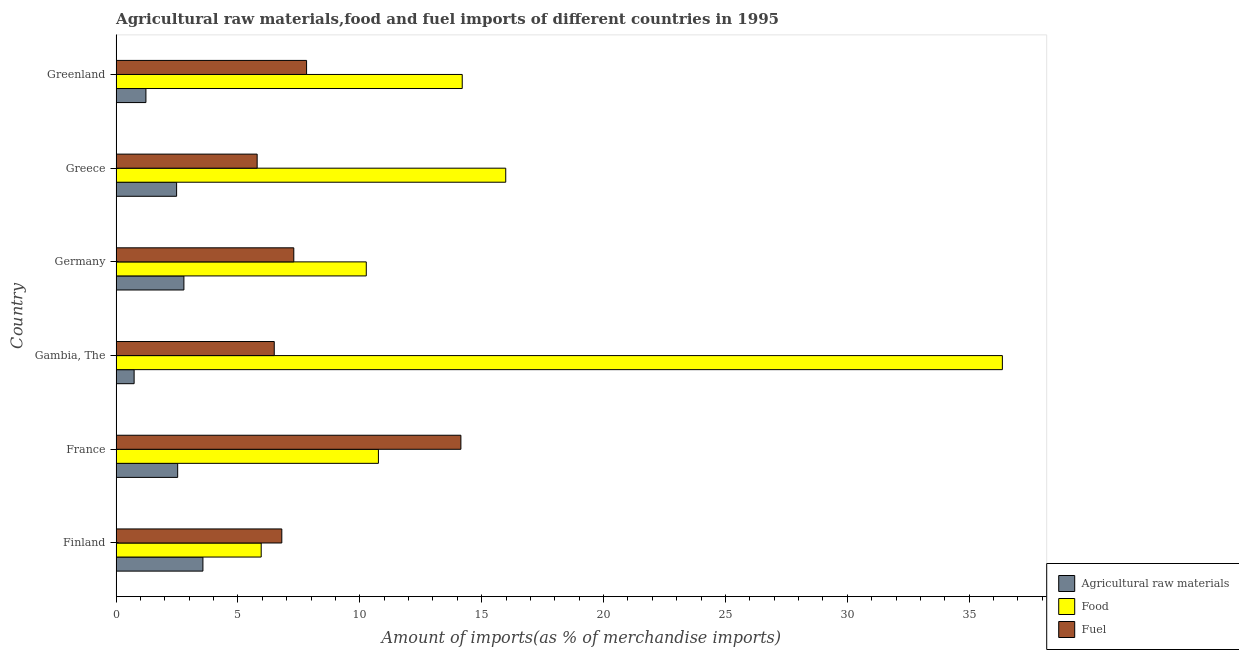How many different coloured bars are there?
Provide a succinct answer. 3. Are the number of bars per tick equal to the number of legend labels?
Ensure brevity in your answer.  Yes. What is the label of the 1st group of bars from the top?
Offer a very short reply. Greenland. In how many cases, is the number of bars for a given country not equal to the number of legend labels?
Keep it short and to the point. 0. What is the percentage of food imports in Germany?
Offer a terse response. 10.26. Across all countries, what is the maximum percentage of food imports?
Provide a succinct answer. 36.36. Across all countries, what is the minimum percentage of food imports?
Keep it short and to the point. 5.95. In which country was the percentage of food imports maximum?
Give a very brief answer. Gambia, The. What is the total percentage of fuel imports in the graph?
Keep it short and to the point. 48.32. What is the difference between the percentage of raw materials imports in France and that in Gambia, The?
Your answer should be compact. 1.79. What is the difference between the percentage of raw materials imports in Greenland and the percentage of fuel imports in France?
Give a very brief answer. -12.92. What is the average percentage of fuel imports per country?
Offer a terse response. 8.05. What is the difference between the percentage of food imports and percentage of fuel imports in Greenland?
Keep it short and to the point. 6.39. In how many countries, is the percentage of raw materials imports greater than 9 %?
Your response must be concise. 0. What is the ratio of the percentage of raw materials imports in France to that in Greenland?
Give a very brief answer. 2.06. Is the percentage of fuel imports in Germany less than that in Greece?
Your answer should be very brief. No. Is the difference between the percentage of raw materials imports in Germany and Greenland greater than the difference between the percentage of food imports in Germany and Greenland?
Give a very brief answer. Yes. What is the difference between the highest and the second highest percentage of fuel imports?
Provide a short and direct response. 6.33. What is the difference between the highest and the lowest percentage of fuel imports?
Offer a very short reply. 8.36. In how many countries, is the percentage of food imports greater than the average percentage of food imports taken over all countries?
Offer a terse response. 2. Is the sum of the percentage of food imports in Finland and Germany greater than the maximum percentage of fuel imports across all countries?
Your answer should be compact. Yes. What does the 3rd bar from the top in Finland represents?
Provide a succinct answer. Agricultural raw materials. What does the 1st bar from the bottom in Greece represents?
Your answer should be compact. Agricultural raw materials. Are all the bars in the graph horizontal?
Ensure brevity in your answer.  Yes. How many countries are there in the graph?
Your answer should be very brief. 6. What is the difference between two consecutive major ticks on the X-axis?
Give a very brief answer. 5. Are the values on the major ticks of X-axis written in scientific E-notation?
Make the answer very short. No. Does the graph contain grids?
Your answer should be compact. No. Where does the legend appear in the graph?
Give a very brief answer. Bottom right. What is the title of the graph?
Ensure brevity in your answer.  Agricultural raw materials,food and fuel imports of different countries in 1995. Does "Social Insurance" appear as one of the legend labels in the graph?
Your response must be concise. No. What is the label or title of the X-axis?
Your response must be concise. Amount of imports(as % of merchandise imports). What is the Amount of imports(as % of merchandise imports) in Agricultural raw materials in Finland?
Your answer should be very brief. 3.56. What is the Amount of imports(as % of merchandise imports) in Food in Finland?
Make the answer very short. 5.95. What is the Amount of imports(as % of merchandise imports) of Fuel in Finland?
Your answer should be very brief. 6.8. What is the Amount of imports(as % of merchandise imports) of Agricultural raw materials in France?
Your response must be concise. 2.53. What is the Amount of imports(as % of merchandise imports) of Food in France?
Provide a succinct answer. 10.76. What is the Amount of imports(as % of merchandise imports) of Fuel in France?
Provide a short and direct response. 14.15. What is the Amount of imports(as % of merchandise imports) of Agricultural raw materials in Gambia, The?
Make the answer very short. 0.74. What is the Amount of imports(as % of merchandise imports) of Food in Gambia, The?
Offer a very short reply. 36.36. What is the Amount of imports(as % of merchandise imports) of Fuel in Gambia, The?
Provide a succinct answer. 6.49. What is the Amount of imports(as % of merchandise imports) in Agricultural raw materials in Germany?
Ensure brevity in your answer.  2.78. What is the Amount of imports(as % of merchandise imports) in Food in Germany?
Provide a short and direct response. 10.26. What is the Amount of imports(as % of merchandise imports) of Fuel in Germany?
Provide a short and direct response. 7.29. What is the Amount of imports(as % of merchandise imports) of Agricultural raw materials in Greece?
Ensure brevity in your answer.  2.48. What is the Amount of imports(as % of merchandise imports) of Food in Greece?
Make the answer very short. 15.99. What is the Amount of imports(as % of merchandise imports) in Fuel in Greece?
Give a very brief answer. 5.79. What is the Amount of imports(as % of merchandise imports) of Agricultural raw materials in Greenland?
Make the answer very short. 1.22. What is the Amount of imports(as % of merchandise imports) of Food in Greenland?
Your answer should be very brief. 14.2. What is the Amount of imports(as % of merchandise imports) of Fuel in Greenland?
Your response must be concise. 7.81. Across all countries, what is the maximum Amount of imports(as % of merchandise imports) of Agricultural raw materials?
Offer a very short reply. 3.56. Across all countries, what is the maximum Amount of imports(as % of merchandise imports) in Food?
Provide a short and direct response. 36.36. Across all countries, what is the maximum Amount of imports(as % of merchandise imports) of Fuel?
Give a very brief answer. 14.15. Across all countries, what is the minimum Amount of imports(as % of merchandise imports) of Agricultural raw materials?
Provide a succinct answer. 0.74. Across all countries, what is the minimum Amount of imports(as % of merchandise imports) of Food?
Make the answer very short. 5.95. Across all countries, what is the minimum Amount of imports(as % of merchandise imports) of Fuel?
Give a very brief answer. 5.79. What is the total Amount of imports(as % of merchandise imports) of Agricultural raw materials in the graph?
Provide a succinct answer. 13.31. What is the total Amount of imports(as % of merchandise imports) of Food in the graph?
Provide a short and direct response. 93.53. What is the total Amount of imports(as % of merchandise imports) of Fuel in the graph?
Ensure brevity in your answer.  48.32. What is the difference between the Amount of imports(as % of merchandise imports) in Agricultural raw materials in Finland and that in France?
Provide a short and direct response. 1.04. What is the difference between the Amount of imports(as % of merchandise imports) of Food in Finland and that in France?
Give a very brief answer. -4.81. What is the difference between the Amount of imports(as % of merchandise imports) in Fuel in Finland and that in France?
Offer a very short reply. -7.35. What is the difference between the Amount of imports(as % of merchandise imports) in Agricultural raw materials in Finland and that in Gambia, The?
Your response must be concise. 2.82. What is the difference between the Amount of imports(as % of merchandise imports) of Food in Finland and that in Gambia, The?
Ensure brevity in your answer.  -30.41. What is the difference between the Amount of imports(as % of merchandise imports) of Fuel in Finland and that in Gambia, The?
Make the answer very short. 0.31. What is the difference between the Amount of imports(as % of merchandise imports) in Agricultural raw materials in Finland and that in Germany?
Make the answer very short. 0.78. What is the difference between the Amount of imports(as % of merchandise imports) of Food in Finland and that in Germany?
Provide a succinct answer. -4.31. What is the difference between the Amount of imports(as % of merchandise imports) of Fuel in Finland and that in Germany?
Keep it short and to the point. -0.49. What is the difference between the Amount of imports(as % of merchandise imports) in Agricultural raw materials in Finland and that in Greece?
Give a very brief answer. 1.08. What is the difference between the Amount of imports(as % of merchandise imports) of Food in Finland and that in Greece?
Your answer should be very brief. -10.03. What is the difference between the Amount of imports(as % of merchandise imports) of Fuel in Finland and that in Greece?
Provide a succinct answer. 1.01. What is the difference between the Amount of imports(as % of merchandise imports) of Agricultural raw materials in Finland and that in Greenland?
Your answer should be very brief. 2.34. What is the difference between the Amount of imports(as % of merchandise imports) in Food in Finland and that in Greenland?
Give a very brief answer. -8.25. What is the difference between the Amount of imports(as % of merchandise imports) of Fuel in Finland and that in Greenland?
Make the answer very short. -1.02. What is the difference between the Amount of imports(as % of merchandise imports) of Agricultural raw materials in France and that in Gambia, The?
Provide a short and direct response. 1.79. What is the difference between the Amount of imports(as % of merchandise imports) in Food in France and that in Gambia, The?
Offer a terse response. -25.6. What is the difference between the Amount of imports(as % of merchandise imports) in Fuel in France and that in Gambia, The?
Offer a terse response. 7.66. What is the difference between the Amount of imports(as % of merchandise imports) of Agricultural raw materials in France and that in Germany?
Ensure brevity in your answer.  -0.26. What is the difference between the Amount of imports(as % of merchandise imports) in Food in France and that in Germany?
Make the answer very short. 0.5. What is the difference between the Amount of imports(as % of merchandise imports) of Fuel in France and that in Germany?
Offer a very short reply. 6.86. What is the difference between the Amount of imports(as % of merchandise imports) of Agricultural raw materials in France and that in Greece?
Your answer should be very brief. 0.04. What is the difference between the Amount of imports(as % of merchandise imports) in Food in France and that in Greece?
Provide a short and direct response. -5.22. What is the difference between the Amount of imports(as % of merchandise imports) in Fuel in France and that in Greece?
Keep it short and to the point. 8.36. What is the difference between the Amount of imports(as % of merchandise imports) of Agricultural raw materials in France and that in Greenland?
Offer a terse response. 1.3. What is the difference between the Amount of imports(as % of merchandise imports) of Food in France and that in Greenland?
Make the answer very short. -3.44. What is the difference between the Amount of imports(as % of merchandise imports) of Fuel in France and that in Greenland?
Your answer should be compact. 6.33. What is the difference between the Amount of imports(as % of merchandise imports) of Agricultural raw materials in Gambia, The and that in Germany?
Your answer should be compact. -2.04. What is the difference between the Amount of imports(as % of merchandise imports) of Food in Gambia, The and that in Germany?
Your answer should be compact. 26.1. What is the difference between the Amount of imports(as % of merchandise imports) in Fuel in Gambia, The and that in Germany?
Your response must be concise. -0.8. What is the difference between the Amount of imports(as % of merchandise imports) of Agricultural raw materials in Gambia, The and that in Greece?
Provide a short and direct response. -1.74. What is the difference between the Amount of imports(as % of merchandise imports) in Food in Gambia, The and that in Greece?
Ensure brevity in your answer.  20.38. What is the difference between the Amount of imports(as % of merchandise imports) of Fuel in Gambia, The and that in Greece?
Provide a short and direct response. 0.7. What is the difference between the Amount of imports(as % of merchandise imports) in Agricultural raw materials in Gambia, The and that in Greenland?
Your answer should be compact. -0.48. What is the difference between the Amount of imports(as % of merchandise imports) of Food in Gambia, The and that in Greenland?
Offer a very short reply. 22.16. What is the difference between the Amount of imports(as % of merchandise imports) in Fuel in Gambia, The and that in Greenland?
Offer a very short reply. -1.33. What is the difference between the Amount of imports(as % of merchandise imports) of Agricultural raw materials in Germany and that in Greece?
Your answer should be compact. 0.3. What is the difference between the Amount of imports(as % of merchandise imports) of Food in Germany and that in Greece?
Your answer should be compact. -5.72. What is the difference between the Amount of imports(as % of merchandise imports) in Fuel in Germany and that in Greece?
Provide a succinct answer. 1.5. What is the difference between the Amount of imports(as % of merchandise imports) in Agricultural raw materials in Germany and that in Greenland?
Offer a terse response. 1.56. What is the difference between the Amount of imports(as % of merchandise imports) in Food in Germany and that in Greenland?
Offer a terse response. -3.94. What is the difference between the Amount of imports(as % of merchandise imports) in Fuel in Germany and that in Greenland?
Ensure brevity in your answer.  -0.52. What is the difference between the Amount of imports(as % of merchandise imports) of Agricultural raw materials in Greece and that in Greenland?
Ensure brevity in your answer.  1.26. What is the difference between the Amount of imports(as % of merchandise imports) of Food in Greece and that in Greenland?
Offer a terse response. 1.78. What is the difference between the Amount of imports(as % of merchandise imports) in Fuel in Greece and that in Greenland?
Offer a very short reply. -2.03. What is the difference between the Amount of imports(as % of merchandise imports) of Agricultural raw materials in Finland and the Amount of imports(as % of merchandise imports) of Food in France?
Keep it short and to the point. -7.2. What is the difference between the Amount of imports(as % of merchandise imports) of Agricultural raw materials in Finland and the Amount of imports(as % of merchandise imports) of Fuel in France?
Your answer should be very brief. -10.58. What is the difference between the Amount of imports(as % of merchandise imports) of Food in Finland and the Amount of imports(as % of merchandise imports) of Fuel in France?
Offer a very short reply. -8.19. What is the difference between the Amount of imports(as % of merchandise imports) in Agricultural raw materials in Finland and the Amount of imports(as % of merchandise imports) in Food in Gambia, The?
Offer a very short reply. -32.8. What is the difference between the Amount of imports(as % of merchandise imports) in Agricultural raw materials in Finland and the Amount of imports(as % of merchandise imports) in Fuel in Gambia, The?
Keep it short and to the point. -2.93. What is the difference between the Amount of imports(as % of merchandise imports) of Food in Finland and the Amount of imports(as % of merchandise imports) of Fuel in Gambia, The?
Give a very brief answer. -0.54. What is the difference between the Amount of imports(as % of merchandise imports) of Agricultural raw materials in Finland and the Amount of imports(as % of merchandise imports) of Food in Germany?
Provide a succinct answer. -6.7. What is the difference between the Amount of imports(as % of merchandise imports) in Agricultural raw materials in Finland and the Amount of imports(as % of merchandise imports) in Fuel in Germany?
Keep it short and to the point. -3.73. What is the difference between the Amount of imports(as % of merchandise imports) of Food in Finland and the Amount of imports(as % of merchandise imports) of Fuel in Germany?
Give a very brief answer. -1.34. What is the difference between the Amount of imports(as % of merchandise imports) of Agricultural raw materials in Finland and the Amount of imports(as % of merchandise imports) of Food in Greece?
Ensure brevity in your answer.  -12.43. What is the difference between the Amount of imports(as % of merchandise imports) of Agricultural raw materials in Finland and the Amount of imports(as % of merchandise imports) of Fuel in Greece?
Your answer should be compact. -2.23. What is the difference between the Amount of imports(as % of merchandise imports) of Food in Finland and the Amount of imports(as % of merchandise imports) of Fuel in Greece?
Give a very brief answer. 0.17. What is the difference between the Amount of imports(as % of merchandise imports) in Agricultural raw materials in Finland and the Amount of imports(as % of merchandise imports) in Food in Greenland?
Offer a very short reply. -10.64. What is the difference between the Amount of imports(as % of merchandise imports) of Agricultural raw materials in Finland and the Amount of imports(as % of merchandise imports) of Fuel in Greenland?
Give a very brief answer. -4.25. What is the difference between the Amount of imports(as % of merchandise imports) of Food in Finland and the Amount of imports(as % of merchandise imports) of Fuel in Greenland?
Offer a very short reply. -1.86. What is the difference between the Amount of imports(as % of merchandise imports) of Agricultural raw materials in France and the Amount of imports(as % of merchandise imports) of Food in Gambia, The?
Keep it short and to the point. -33.84. What is the difference between the Amount of imports(as % of merchandise imports) of Agricultural raw materials in France and the Amount of imports(as % of merchandise imports) of Fuel in Gambia, The?
Provide a short and direct response. -3.96. What is the difference between the Amount of imports(as % of merchandise imports) in Food in France and the Amount of imports(as % of merchandise imports) in Fuel in Gambia, The?
Your response must be concise. 4.27. What is the difference between the Amount of imports(as % of merchandise imports) of Agricultural raw materials in France and the Amount of imports(as % of merchandise imports) of Food in Germany?
Give a very brief answer. -7.74. What is the difference between the Amount of imports(as % of merchandise imports) of Agricultural raw materials in France and the Amount of imports(as % of merchandise imports) of Fuel in Germany?
Your answer should be compact. -4.77. What is the difference between the Amount of imports(as % of merchandise imports) of Food in France and the Amount of imports(as % of merchandise imports) of Fuel in Germany?
Your answer should be compact. 3.47. What is the difference between the Amount of imports(as % of merchandise imports) of Agricultural raw materials in France and the Amount of imports(as % of merchandise imports) of Food in Greece?
Keep it short and to the point. -13.46. What is the difference between the Amount of imports(as % of merchandise imports) in Agricultural raw materials in France and the Amount of imports(as % of merchandise imports) in Fuel in Greece?
Offer a very short reply. -3.26. What is the difference between the Amount of imports(as % of merchandise imports) of Food in France and the Amount of imports(as % of merchandise imports) of Fuel in Greece?
Offer a terse response. 4.98. What is the difference between the Amount of imports(as % of merchandise imports) in Agricultural raw materials in France and the Amount of imports(as % of merchandise imports) in Food in Greenland?
Make the answer very short. -11.68. What is the difference between the Amount of imports(as % of merchandise imports) of Agricultural raw materials in France and the Amount of imports(as % of merchandise imports) of Fuel in Greenland?
Provide a succinct answer. -5.29. What is the difference between the Amount of imports(as % of merchandise imports) of Food in France and the Amount of imports(as % of merchandise imports) of Fuel in Greenland?
Your answer should be very brief. 2.95. What is the difference between the Amount of imports(as % of merchandise imports) in Agricultural raw materials in Gambia, The and the Amount of imports(as % of merchandise imports) in Food in Germany?
Offer a very short reply. -9.53. What is the difference between the Amount of imports(as % of merchandise imports) of Agricultural raw materials in Gambia, The and the Amount of imports(as % of merchandise imports) of Fuel in Germany?
Offer a very short reply. -6.55. What is the difference between the Amount of imports(as % of merchandise imports) in Food in Gambia, The and the Amount of imports(as % of merchandise imports) in Fuel in Germany?
Your response must be concise. 29.07. What is the difference between the Amount of imports(as % of merchandise imports) of Agricultural raw materials in Gambia, The and the Amount of imports(as % of merchandise imports) of Food in Greece?
Give a very brief answer. -15.25. What is the difference between the Amount of imports(as % of merchandise imports) of Agricultural raw materials in Gambia, The and the Amount of imports(as % of merchandise imports) of Fuel in Greece?
Make the answer very short. -5.05. What is the difference between the Amount of imports(as % of merchandise imports) of Food in Gambia, The and the Amount of imports(as % of merchandise imports) of Fuel in Greece?
Give a very brief answer. 30.58. What is the difference between the Amount of imports(as % of merchandise imports) of Agricultural raw materials in Gambia, The and the Amount of imports(as % of merchandise imports) of Food in Greenland?
Your answer should be compact. -13.46. What is the difference between the Amount of imports(as % of merchandise imports) of Agricultural raw materials in Gambia, The and the Amount of imports(as % of merchandise imports) of Fuel in Greenland?
Keep it short and to the point. -7.08. What is the difference between the Amount of imports(as % of merchandise imports) in Food in Gambia, The and the Amount of imports(as % of merchandise imports) in Fuel in Greenland?
Your answer should be very brief. 28.55. What is the difference between the Amount of imports(as % of merchandise imports) in Agricultural raw materials in Germany and the Amount of imports(as % of merchandise imports) in Food in Greece?
Keep it short and to the point. -13.21. What is the difference between the Amount of imports(as % of merchandise imports) in Agricultural raw materials in Germany and the Amount of imports(as % of merchandise imports) in Fuel in Greece?
Ensure brevity in your answer.  -3.01. What is the difference between the Amount of imports(as % of merchandise imports) of Food in Germany and the Amount of imports(as % of merchandise imports) of Fuel in Greece?
Ensure brevity in your answer.  4.48. What is the difference between the Amount of imports(as % of merchandise imports) of Agricultural raw materials in Germany and the Amount of imports(as % of merchandise imports) of Food in Greenland?
Offer a very short reply. -11.42. What is the difference between the Amount of imports(as % of merchandise imports) in Agricultural raw materials in Germany and the Amount of imports(as % of merchandise imports) in Fuel in Greenland?
Provide a succinct answer. -5.03. What is the difference between the Amount of imports(as % of merchandise imports) of Food in Germany and the Amount of imports(as % of merchandise imports) of Fuel in Greenland?
Your answer should be very brief. 2.45. What is the difference between the Amount of imports(as % of merchandise imports) in Agricultural raw materials in Greece and the Amount of imports(as % of merchandise imports) in Food in Greenland?
Your answer should be very brief. -11.72. What is the difference between the Amount of imports(as % of merchandise imports) in Agricultural raw materials in Greece and the Amount of imports(as % of merchandise imports) in Fuel in Greenland?
Keep it short and to the point. -5.33. What is the difference between the Amount of imports(as % of merchandise imports) in Food in Greece and the Amount of imports(as % of merchandise imports) in Fuel in Greenland?
Offer a very short reply. 8.17. What is the average Amount of imports(as % of merchandise imports) of Agricultural raw materials per country?
Make the answer very short. 2.22. What is the average Amount of imports(as % of merchandise imports) of Food per country?
Your response must be concise. 15.59. What is the average Amount of imports(as % of merchandise imports) in Fuel per country?
Your response must be concise. 8.05. What is the difference between the Amount of imports(as % of merchandise imports) in Agricultural raw materials and Amount of imports(as % of merchandise imports) in Food in Finland?
Provide a succinct answer. -2.39. What is the difference between the Amount of imports(as % of merchandise imports) of Agricultural raw materials and Amount of imports(as % of merchandise imports) of Fuel in Finland?
Your response must be concise. -3.24. What is the difference between the Amount of imports(as % of merchandise imports) of Food and Amount of imports(as % of merchandise imports) of Fuel in Finland?
Your response must be concise. -0.85. What is the difference between the Amount of imports(as % of merchandise imports) in Agricultural raw materials and Amount of imports(as % of merchandise imports) in Food in France?
Your answer should be very brief. -8.24. What is the difference between the Amount of imports(as % of merchandise imports) of Agricultural raw materials and Amount of imports(as % of merchandise imports) of Fuel in France?
Offer a terse response. -11.62. What is the difference between the Amount of imports(as % of merchandise imports) in Food and Amount of imports(as % of merchandise imports) in Fuel in France?
Offer a terse response. -3.38. What is the difference between the Amount of imports(as % of merchandise imports) of Agricultural raw materials and Amount of imports(as % of merchandise imports) of Food in Gambia, The?
Offer a very short reply. -35.63. What is the difference between the Amount of imports(as % of merchandise imports) of Agricultural raw materials and Amount of imports(as % of merchandise imports) of Fuel in Gambia, The?
Keep it short and to the point. -5.75. What is the difference between the Amount of imports(as % of merchandise imports) of Food and Amount of imports(as % of merchandise imports) of Fuel in Gambia, The?
Your answer should be compact. 29.88. What is the difference between the Amount of imports(as % of merchandise imports) of Agricultural raw materials and Amount of imports(as % of merchandise imports) of Food in Germany?
Your answer should be compact. -7.48. What is the difference between the Amount of imports(as % of merchandise imports) in Agricultural raw materials and Amount of imports(as % of merchandise imports) in Fuel in Germany?
Your answer should be very brief. -4.51. What is the difference between the Amount of imports(as % of merchandise imports) of Food and Amount of imports(as % of merchandise imports) of Fuel in Germany?
Give a very brief answer. 2.97. What is the difference between the Amount of imports(as % of merchandise imports) in Agricultural raw materials and Amount of imports(as % of merchandise imports) in Food in Greece?
Ensure brevity in your answer.  -13.5. What is the difference between the Amount of imports(as % of merchandise imports) in Agricultural raw materials and Amount of imports(as % of merchandise imports) in Fuel in Greece?
Make the answer very short. -3.3. What is the difference between the Amount of imports(as % of merchandise imports) in Food and Amount of imports(as % of merchandise imports) in Fuel in Greece?
Provide a succinct answer. 10.2. What is the difference between the Amount of imports(as % of merchandise imports) in Agricultural raw materials and Amount of imports(as % of merchandise imports) in Food in Greenland?
Give a very brief answer. -12.98. What is the difference between the Amount of imports(as % of merchandise imports) in Agricultural raw materials and Amount of imports(as % of merchandise imports) in Fuel in Greenland?
Provide a succinct answer. -6.59. What is the difference between the Amount of imports(as % of merchandise imports) of Food and Amount of imports(as % of merchandise imports) of Fuel in Greenland?
Keep it short and to the point. 6.39. What is the ratio of the Amount of imports(as % of merchandise imports) of Agricultural raw materials in Finland to that in France?
Your answer should be very brief. 1.41. What is the ratio of the Amount of imports(as % of merchandise imports) in Food in Finland to that in France?
Provide a short and direct response. 0.55. What is the ratio of the Amount of imports(as % of merchandise imports) in Fuel in Finland to that in France?
Keep it short and to the point. 0.48. What is the ratio of the Amount of imports(as % of merchandise imports) of Agricultural raw materials in Finland to that in Gambia, The?
Give a very brief answer. 4.82. What is the ratio of the Amount of imports(as % of merchandise imports) of Food in Finland to that in Gambia, The?
Offer a terse response. 0.16. What is the ratio of the Amount of imports(as % of merchandise imports) of Fuel in Finland to that in Gambia, The?
Your answer should be compact. 1.05. What is the ratio of the Amount of imports(as % of merchandise imports) of Agricultural raw materials in Finland to that in Germany?
Your answer should be compact. 1.28. What is the ratio of the Amount of imports(as % of merchandise imports) in Food in Finland to that in Germany?
Give a very brief answer. 0.58. What is the ratio of the Amount of imports(as % of merchandise imports) of Fuel in Finland to that in Germany?
Offer a very short reply. 0.93. What is the ratio of the Amount of imports(as % of merchandise imports) of Agricultural raw materials in Finland to that in Greece?
Offer a very short reply. 1.43. What is the ratio of the Amount of imports(as % of merchandise imports) in Food in Finland to that in Greece?
Keep it short and to the point. 0.37. What is the ratio of the Amount of imports(as % of merchandise imports) of Fuel in Finland to that in Greece?
Ensure brevity in your answer.  1.17. What is the ratio of the Amount of imports(as % of merchandise imports) of Agricultural raw materials in Finland to that in Greenland?
Provide a short and direct response. 2.91. What is the ratio of the Amount of imports(as % of merchandise imports) in Food in Finland to that in Greenland?
Give a very brief answer. 0.42. What is the ratio of the Amount of imports(as % of merchandise imports) of Fuel in Finland to that in Greenland?
Offer a very short reply. 0.87. What is the ratio of the Amount of imports(as % of merchandise imports) in Agricultural raw materials in France to that in Gambia, The?
Give a very brief answer. 3.42. What is the ratio of the Amount of imports(as % of merchandise imports) of Food in France to that in Gambia, The?
Give a very brief answer. 0.3. What is the ratio of the Amount of imports(as % of merchandise imports) of Fuel in France to that in Gambia, The?
Provide a succinct answer. 2.18. What is the ratio of the Amount of imports(as % of merchandise imports) in Agricultural raw materials in France to that in Germany?
Offer a very short reply. 0.91. What is the ratio of the Amount of imports(as % of merchandise imports) of Food in France to that in Germany?
Provide a short and direct response. 1.05. What is the ratio of the Amount of imports(as % of merchandise imports) in Fuel in France to that in Germany?
Your answer should be compact. 1.94. What is the ratio of the Amount of imports(as % of merchandise imports) of Agricultural raw materials in France to that in Greece?
Provide a short and direct response. 1.02. What is the ratio of the Amount of imports(as % of merchandise imports) in Food in France to that in Greece?
Provide a succinct answer. 0.67. What is the ratio of the Amount of imports(as % of merchandise imports) of Fuel in France to that in Greece?
Your answer should be very brief. 2.44. What is the ratio of the Amount of imports(as % of merchandise imports) of Agricultural raw materials in France to that in Greenland?
Your answer should be compact. 2.07. What is the ratio of the Amount of imports(as % of merchandise imports) in Food in France to that in Greenland?
Offer a very short reply. 0.76. What is the ratio of the Amount of imports(as % of merchandise imports) in Fuel in France to that in Greenland?
Make the answer very short. 1.81. What is the ratio of the Amount of imports(as % of merchandise imports) of Agricultural raw materials in Gambia, The to that in Germany?
Provide a succinct answer. 0.27. What is the ratio of the Amount of imports(as % of merchandise imports) in Food in Gambia, The to that in Germany?
Your answer should be compact. 3.54. What is the ratio of the Amount of imports(as % of merchandise imports) in Fuel in Gambia, The to that in Germany?
Offer a terse response. 0.89. What is the ratio of the Amount of imports(as % of merchandise imports) in Agricultural raw materials in Gambia, The to that in Greece?
Ensure brevity in your answer.  0.3. What is the ratio of the Amount of imports(as % of merchandise imports) in Food in Gambia, The to that in Greece?
Provide a succinct answer. 2.27. What is the ratio of the Amount of imports(as % of merchandise imports) of Fuel in Gambia, The to that in Greece?
Your answer should be very brief. 1.12. What is the ratio of the Amount of imports(as % of merchandise imports) in Agricultural raw materials in Gambia, The to that in Greenland?
Provide a succinct answer. 0.6. What is the ratio of the Amount of imports(as % of merchandise imports) in Food in Gambia, The to that in Greenland?
Provide a short and direct response. 2.56. What is the ratio of the Amount of imports(as % of merchandise imports) in Fuel in Gambia, The to that in Greenland?
Provide a short and direct response. 0.83. What is the ratio of the Amount of imports(as % of merchandise imports) in Agricultural raw materials in Germany to that in Greece?
Make the answer very short. 1.12. What is the ratio of the Amount of imports(as % of merchandise imports) of Food in Germany to that in Greece?
Your answer should be compact. 0.64. What is the ratio of the Amount of imports(as % of merchandise imports) in Fuel in Germany to that in Greece?
Provide a succinct answer. 1.26. What is the ratio of the Amount of imports(as % of merchandise imports) of Agricultural raw materials in Germany to that in Greenland?
Provide a short and direct response. 2.27. What is the ratio of the Amount of imports(as % of merchandise imports) in Food in Germany to that in Greenland?
Give a very brief answer. 0.72. What is the ratio of the Amount of imports(as % of merchandise imports) of Fuel in Germany to that in Greenland?
Your answer should be very brief. 0.93. What is the ratio of the Amount of imports(as % of merchandise imports) in Agricultural raw materials in Greece to that in Greenland?
Your response must be concise. 2.03. What is the ratio of the Amount of imports(as % of merchandise imports) in Food in Greece to that in Greenland?
Provide a succinct answer. 1.13. What is the ratio of the Amount of imports(as % of merchandise imports) of Fuel in Greece to that in Greenland?
Provide a succinct answer. 0.74. What is the difference between the highest and the second highest Amount of imports(as % of merchandise imports) in Agricultural raw materials?
Give a very brief answer. 0.78. What is the difference between the highest and the second highest Amount of imports(as % of merchandise imports) in Food?
Keep it short and to the point. 20.38. What is the difference between the highest and the second highest Amount of imports(as % of merchandise imports) in Fuel?
Your answer should be very brief. 6.33. What is the difference between the highest and the lowest Amount of imports(as % of merchandise imports) of Agricultural raw materials?
Offer a terse response. 2.82. What is the difference between the highest and the lowest Amount of imports(as % of merchandise imports) in Food?
Your answer should be compact. 30.41. What is the difference between the highest and the lowest Amount of imports(as % of merchandise imports) of Fuel?
Make the answer very short. 8.36. 